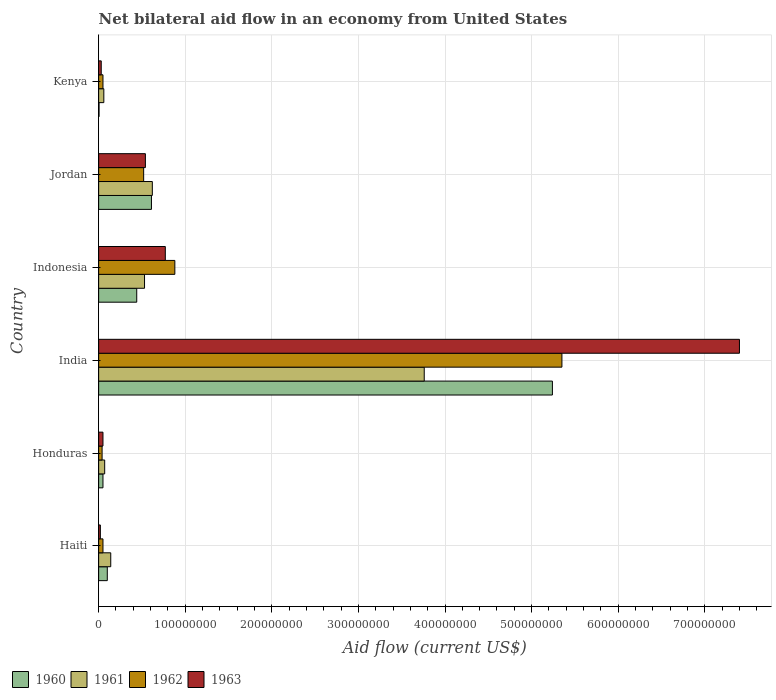Are the number of bars per tick equal to the number of legend labels?
Give a very brief answer. Yes. How many bars are there on the 6th tick from the top?
Ensure brevity in your answer.  4. What is the label of the 6th group of bars from the top?
Your response must be concise. Haiti. In how many cases, is the number of bars for a given country not equal to the number of legend labels?
Ensure brevity in your answer.  0. Across all countries, what is the maximum net bilateral aid flow in 1960?
Keep it short and to the point. 5.24e+08. In which country was the net bilateral aid flow in 1962 maximum?
Offer a terse response. India. In which country was the net bilateral aid flow in 1962 minimum?
Your answer should be very brief. Honduras. What is the total net bilateral aid flow in 1960 in the graph?
Provide a short and direct response. 6.44e+08. What is the difference between the net bilateral aid flow in 1963 in India and that in Kenya?
Keep it short and to the point. 7.37e+08. What is the difference between the net bilateral aid flow in 1962 in Kenya and the net bilateral aid flow in 1960 in Honduras?
Ensure brevity in your answer.  0. What is the average net bilateral aid flow in 1963 per country?
Offer a terse response. 1.47e+08. What is the difference between the net bilateral aid flow in 1962 and net bilateral aid flow in 1960 in Honduras?
Provide a succinct answer. -1.00e+06. What is the ratio of the net bilateral aid flow in 1962 in Honduras to that in India?
Give a very brief answer. 0.01. What is the difference between the highest and the second highest net bilateral aid flow in 1960?
Offer a very short reply. 4.63e+08. What is the difference between the highest and the lowest net bilateral aid flow in 1963?
Offer a very short reply. 7.38e+08. Is the sum of the net bilateral aid flow in 1962 in Indonesia and Jordan greater than the maximum net bilateral aid flow in 1960 across all countries?
Your answer should be very brief. No. What does the 2nd bar from the top in India represents?
Your response must be concise. 1962. How many bars are there?
Offer a very short reply. 24. How many countries are there in the graph?
Provide a short and direct response. 6. Does the graph contain grids?
Provide a succinct answer. Yes. Where does the legend appear in the graph?
Offer a terse response. Bottom left. How are the legend labels stacked?
Offer a very short reply. Horizontal. What is the title of the graph?
Ensure brevity in your answer.  Net bilateral aid flow in an economy from United States. What is the label or title of the X-axis?
Give a very brief answer. Aid flow (current US$). What is the Aid flow (current US$) of 1961 in Haiti?
Give a very brief answer. 1.40e+07. What is the Aid flow (current US$) in 1962 in Haiti?
Offer a very short reply. 5.00e+06. What is the Aid flow (current US$) of 1963 in Haiti?
Ensure brevity in your answer.  2.00e+06. What is the Aid flow (current US$) in 1960 in Honduras?
Provide a succinct answer. 5.00e+06. What is the Aid flow (current US$) of 1962 in Honduras?
Offer a very short reply. 4.00e+06. What is the Aid flow (current US$) in 1960 in India?
Provide a short and direct response. 5.24e+08. What is the Aid flow (current US$) in 1961 in India?
Ensure brevity in your answer.  3.76e+08. What is the Aid flow (current US$) in 1962 in India?
Keep it short and to the point. 5.35e+08. What is the Aid flow (current US$) of 1963 in India?
Give a very brief answer. 7.40e+08. What is the Aid flow (current US$) of 1960 in Indonesia?
Give a very brief answer. 4.40e+07. What is the Aid flow (current US$) of 1961 in Indonesia?
Offer a terse response. 5.30e+07. What is the Aid flow (current US$) in 1962 in Indonesia?
Offer a terse response. 8.80e+07. What is the Aid flow (current US$) in 1963 in Indonesia?
Make the answer very short. 7.70e+07. What is the Aid flow (current US$) in 1960 in Jordan?
Make the answer very short. 6.10e+07. What is the Aid flow (current US$) in 1961 in Jordan?
Ensure brevity in your answer.  6.20e+07. What is the Aid flow (current US$) in 1962 in Jordan?
Make the answer very short. 5.20e+07. What is the Aid flow (current US$) of 1963 in Jordan?
Ensure brevity in your answer.  5.40e+07. What is the Aid flow (current US$) in 1962 in Kenya?
Provide a succinct answer. 5.00e+06. What is the Aid flow (current US$) of 1963 in Kenya?
Your answer should be very brief. 3.00e+06. Across all countries, what is the maximum Aid flow (current US$) of 1960?
Provide a short and direct response. 5.24e+08. Across all countries, what is the maximum Aid flow (current US$) of 1961?
Offer a terse response. 3.76e+08. Across all countries, what is the maximum Aid flow (current US$) of 1962?
Keep it short and to the point. 5.35e+08. Across all countries, what is the maximum Aid flow (current US$) of 1963?
Provide a short and direct response. 7.40e+08. Across all countries, what is the minimum Aid flow (current US$) of 1961?
Provide a succinct answer. 6.00e+06. Across all countries, what is the minimum Aid flow (current US$) in 1962?
Provide a short and direct response. 4.00e+06. What is the total Aid flow (current US$) of 1960 in the graph?
Provide a short and direct response. 6.44e+08. What is the total Aid flow (current US$) of 1961 in the graph?
Provide a succinct answer. 5.18e+08. What is the total Aid flow (current US$) in 1962 in the graph?
Your response must be concise. 6.89e+08. What is the total Aid flow (current US$) of 1963 in the graph?
Give a very brief answer. 8.81e+08. What is the difference between the Aid flow (current US$) in 1960 in Haiti and that in Honduras?
Make the answer very short. 5.00e+06. What is the difference between the Aid flow (current US$) in 1961 in Haiti and that in Honduras?
Give a very brief answer. 7.00e+06. What is the difference between the Aid flow (current US$) in 1960 in Haiti and that in India?
Offer a very short reply. -5.14e+08. What is the difference between the Aid flow (current US$) of 1961 in Haiti and that in India?
Provide a short and direct response. -3.62e+08. What is the difference between the Aid flow (current US$) of 1962 in Haiti and that in India?
Your answer should be very brief. -5.30e+08. What is the difference between the Aid flow (current US$) of 1963 in Haiti and that in India?
Provide a succinct answer. -7.38e+08. What is the difference between the Aid flow (current US$) of 1960 in Haiti and that in Indonesia?
Provide a short and direct response. -3.40e+07. What is the difference between the Aid flow (current US$) in 1961 in Haiti and that in Indonesia?
Ensure brevity in your answer.  -3.90e+07. What is the difference between the Aid flow (current US$) of 1962 in Haiti and that in Indonesia?
Your answer should be compact. -8.30e+07. What is the difference between the Aid flow (current US$) of 1963 in Haiti and that in Indonesia?
Your answer should be very brief. -7.50e+07. What is the difference between the Aid flow (current US$) of 1960 in Haiti and that in Jordan?
Your answer should be very brief. -5.10e+07. What is the difference between the Aid flow (current US$) of 1961 in Haiti and that in Jordan?
Give a very brief answer. -4.80e+07. What is the difference between the Aid flow (current US$) in 1962 in Haiti and that in Jordan?
Offer a very short reply. -4.70e+07. What is the difference between the Aid flow (current US$) in 1963 in Haiti and that in Jordan?
Give a very brief answer. -5.20e+07. What is the difference between the Aid flow (current US$) in 1960 in Haiti and that in Kenya?
Your answer should be compact. 9.52e+06. What is the difference between the Aid flow (current US$) in 1961 in Haiti and that in Kenya?
Provide a short and direct response. 8.00e+06. What is the difference between the Aid flow (current US$) in 1962 in Haiti and that in Kenya?
Offer a terse response. 0. What is the difference between the Aid flow (current US$) of 1960 in Honduras and that in India?
Your response must be concise. -5.19e+08. What is the difference between the Aid flow (current US$) in 1961 in Honduras and that in India?
Provide a succinct answer. -3.69e+08. What is the difference between the Aid flow (current US$) in 1962 in Honduras and that in India?
Make the answer very short. -5.31e+08. What is the difference between the Aid flow (current US$) in 1963 in Honduras and that in India?
Your answer should be compact. -7.35e+08. What is the difference between the Aid flow (current US$) of 1960 in Honduras and that in Indonesia?
Your answer should be compact. -3.90e+07. What is the difference between the Aid flow (current US$) of 1961 in Honduras and that in Indonesia?
Make the answer very short. -4.60e+07. What is the difference between the Aid flow (current US$) in 1962 in Honduras and that in Indonesia?
Make the answer very short. -8.40e+07. What is the difference between the Aid flow (current US$) of 1963 in Honduras and that in Indonesia?
Offer a terse response. -7.20e+07. What is the difference between the Aid flow (current US$) in 1960 in Honduras and that in Jordan?
Keep it short and to the point. -5.60e+07. What is the difference between the Aid flow (current US$) of 1961 in Honduras and that in Jordan?
Ensure brevity in your answer.  -5.50e+07. What is the difference between the Aid flow (current US$) of 1962 in Honduras and that in Jordan?
Provide a short and direct response. -4.80e+07. What is the difference between the Aid flow (current US$) of 1963 in Honduras and that in Jordan?
Offer a very short reply. -4.90e+07. What is the difference between the Aid flow (current US$) in 1960 in Honduras and that in Kenya?
Keep it short and to the point. 4.52e+06. What is the difference between the Aid flow (current US$) in 1961 in Honduras and that in Kenya?
Your answer should be very brief. 1.00e+06. What is the difference between the Aid flow (current US$) of 1962 in Honduras and that in Kenya?
Keep it short and to the point. -1.00e+06. What is the difference between the Aid flow (current US$) in 1963 in Honduras and that in Kenya?
Make the answer very short. 2.00e+06. What is the difference between the Aid flow (current US$) in 1960 in India and that in Indonesia?
Provide a short and direct response. 4.80e+08. What is the difference between the Aid flow (current US$) in 1961 in India and that in Indonesia?
Offer a terse response. 3.23e+08. What is the difference between the Aid flow (current US$) of 1962 in India and that in Indonesia?
Give a very brief answer. 4.47e+08. What is the difference between the Aid flow (current US$) in 1963 in India and that in Indonesia?
Offer a very short reply. 6.63e+08. What is the difference between the Aid flow (current US$) in 1960 in India and that in Jordan?
Provide a succinct answer. 4.63e+08. What is the difference between the Aid flow (current US$) of 1961 in India and that in Jordan?
Ensure brevity in your answer.  3.14e+08. What is the difference between the Aid flow (current US$) of 1962 in India and that in Jordan?
Give a very brief answer. 4.83e+08. What is the difference between the Aid flow (current US$) of 1963 in India and that in Jordan?
Offer a terse response. 6.86e+08. What is the difference between the Aid flow (current US$) of 1960 in India and that in Kenya?
Offer a terse response. 5.24e+08. What is the difference between the Aid flow (current US$) in 1961 in India and that in Kenya?
Give a very brief answer. 3.70e+08. What is the difference between the Aid flow (current US$) in 1962 in India and that in Kenya?
Offer a terse response. 5.30e+08. What is the difference between the Aid flow (current US$) of 1963 in India and that in Kenya?
Offer a very short reply. 7.37e+08. What is the difference between the Aid flow (current US$) of 1960 in Indonesia and that in Jordan?
Make the answer very short. -1.70e+07. What is the difference between the Aid flow (current US$) in 1961 in Indonesia and that in Jordan?
Your response must be concise. -9.00e+06. What is the difference between the Aid flow (current US$) of 1962 in Indonesia and that in Jordan?
Make the answer very short. 3.60e+07. What is the difference between the Aid flow (current US$) in 1963 in Indonesia and that in Jordan?
Keep it short and to the point. 2.30e+07. What is the difference between the Aid flow (current US$) of 1960 in Indonesia and that in Kenya?
Offer a very short reply. 4.35e+07. What is the difference between the Aid flow (current US$) in 1961 in Indonesia and that in Kenya?
Provide a short and direct response. 4.70e+07. What is the difference between the Aid flow (current US$) in 1962 in Indonesia and that in Kenya?
Give a very brief answer. 8.30e+07. What is the difference between the Aid flow (current US$) of 1963 in Indonesia and that in Kenya?
Give a very brief answer. 7.40e+07. What is the difference between the Aid flow (current US$) of 1960 in Jordan and that in Kenya?
Your answer should be very brief. 6.05e+07. What is the difference between the Aid flow (current US$) in 1961 in Jordan and that in Kenya?
Provide a short and direct response. 5.60e+07. What is the difference between the Aid flow (current US$) in 1962 in Jordan and that in Kenya?
Your answer should be very brief. 4.70e+07. What is the difference between the Aid flow (current US$) in 1963 in Jordan and that in Kenya?
Give a very brief answer. 5.10e+07. What is the difference between the Aid flow (current US$) of 1960 in Haiti and the Aid flow (current US$) of 1961 in Honduras?
Provide a succinct answer. 3.00e+06. What is the difference between the Aid flow (current US$) in 1960 in Haiti and the Aid flow (current US$) in 1962 in Honduras?
Give a very brief answer. 6.00e+06. What is the difference between the Aid flow (current US$) in 1961 in Haiti and the Aid flow (current US$) in 1962 in Honduras?
Provide a short and direct response. 1.00e+07. What is the difference between the Aid flow (current US$) in 1961 in Haiti and the Aid flow (current US$) in 1963 in Honduras?
Offer a very short reply. 9.00e+06. What is the difference between the Aid flow (current US$) in 1960 in Haiti and the Aid flow (current US$) in 1961 in India?
Offer a very short reply. -3.66e+08. What is the difference between the Aid flow (current US$) in 1960 in Haiti and the Aid flow (current US$) in 1962 in India?
Your response must be concise. -5.25e+08. What is the difference between the Aid flow (current US$) of 1960 in Haiti and the Aid flow (current US$) of 1963 in India?
Provide a succinct answer. -7.30e+08. What is the difference between the Aid flow (current US$) in 1961 in Haiti and the Aid flow (current US$) in 1962 in India?
Keep it short and to the point. -5.21e+08. What is the difference between the Aid flow (current US$) of 1961 in Haiti and the Aid flow (current US$) of 1963 in India?
Give a very brief answer. -7.26e+08. What is the difference between the Aid flow (current US$) in 1962 in Haiti and the Aid flow (current US$) in 1963 in India?
Offer a terse response. -7.35e+08. What is the difference between the Aid flow (current US$) in 1960 in Haiti and the Aid flow (current US$) in 1961 in Indonesia?
Give a very brief answer. -4.30e+07. What is the difference between the Aid flow (current US$) in 1960 in Haiti and the Aid flow (current US$) in 1962 in Indonesia?
Give a very brief answer. -7.80e+07. What is the difference between the Aid flow (current US$) of 1960 in Haiti and the Aid flow (current US$) of 1963 in Indonesia?
Offer a very short reply. -6.70e+07. What is the difference between the Aid flow (current US$) of 1961 in Haiti and the Aid flow (current US$) of 1962 in Indonesia?
Ensure brevity in your answer.  -7.40e+07. What is the difference between the Aid flow (current US$) of 1961 in Haiti and the Aid flow (current US$) of 1963 in Indonesia?
Give a very brief answer. -6.30e+07. What is the difference between the Aid flow (current US$) in 1962 in Haiti and the Aid flow (current US$) in 1963 in Indonesia?
Make the answer very short. -7.20e+07. What is the difference between the Aid flow (current US$) in 1960 in Haiti and the Aid flow (current US$) in 1961 in Jordan?
Your answer should be very brief. -5.20e+07. What is the difference between the Aid flow (current US$) of 1960 in Haiti and the Aid flow (current US$) of 1962 in Jordan?
Make the answer very short. -4.20e+07. What is the difference between the Aid flow (current US$) of 1960 in Haiti and the Aid flow (current US$) of 1963 in Jordan?
Keep it short and to the point. -4.40e+07. What is the difference between the Aid flow (current US$) in 1961 in Haiti and the Aid flow (current US$) in 1962 in Jordan?
Give a very brief answer. -3.80e+07. What is the difference between the Aid flow (current US$) in 1961 in Haiti and the Aid flow (current US$) in 1963 in Jordan?
Make the answer very short. -4.00e+07. What is the difference between the Aid flow (current US$) of 1962 in Haiti and the Aid flow (current US$) of 1963 in Jordan?
Provide a short and direct response. -4.90e+07. What is the difference between the Aid flow (current US$) of 1960 in Haiti and the Aid flow (current US$) of 1961 in Kenya?
Offer a terse response. 4.00e+06. What is the difference between the Aid flow (current US$) in 1960 in Haiti and the Aid flow (current US$) in 1962 in Kenya?
Keep it short and to the point. 5.00e+06. What is the difference between the Aid flow (current US$) in 1961 in Haiti and the Aid flow (current US$) in 1962 in Kenya?
Give a very brief answer. 9.00e+06. What is the difference between the Aid flow (current US$) of 1961 in Haiti and the Aid flow (current US$) of 1963 in Kenya?
Offer a terse response. 1.10e+07. What is the difference between the Aid flow (current US$) of 1960 in Honduras and the Aid flow (current US$) of 1961 in India?
Offer a very short reply. -3.71e+08. What is the difference between the Aid flow (current US$) of 1960 in Honduras and the Aid flow (current US$) of 1962 in India?
Give a very brief answer. -5.30e+08. What is the difference between the Aid flow (current US$) of 1960 in Honduras and the Aid flow (current US$) of 1963 in India?
Ensure brevity in your answer.  -7.35e+08. What is the difference between the Aid flow (current US$) in 1961 in Honduras and the Aid flow (current US$) in 1962 in India?
Your answer should be compact. -5.28e+08. What is the difference between the Aid flow (current US$) of 1961 in Honduras and the Aid flow (current US$) of 1963 in India?
Provide a short and direct response. -7.33e+08. What is the difference between the Aid flow (current US$) in 1962 in Honduras and the Aid flow (current US$) in 1963 in India?
Make the answer very short. -7.36e+08. What is the difference between the Aid flow (current US$) in 1960 in Honduras and the Aid flow (current US$) in 1961 in Indonesia?
Offer a very short reply. -4.80e+07. What is the difference between the Aid flow (current US$) of 1960 in Honduras and the Aid flow (current US$) of 1962 in Indonesia?
Your answer should be compact. -8.30e+07. What is the difference between the Aid flow (current US$) in 1960 in Honduras and the Aid flow (current US$) in 1963 in Indonesia?
Offer a terse response. -7.20e+07. What is the difference between the Aid flow (current US$) of 1961 in Honduras and the Aid flow (current US$) of 1962 in Indonesia?
Offer a very short reply. -8.10e+07. What is the difference between the Aid flow (current US$) in 1961 in Honduras and the Aid flow (current US$) in 1963 in Indonesia?
Your answer should be compact. -7.00e+07. What is the difference between the Aid flow (current US$) in 1962 in Honduras and the Aid flow (current US$) in 1963 in Indonesia?
Offer a very short reply. -7.30e+07. What is the difference between the Aid flow (current US$) in 1960 in Honduras and the Aid flow (current US$) in 1961 in Jordan?
Ensure brevity in your answer.  -5.70e+07. What is the difference between the Aid flow (current US$) in 1960 in Honduras and the Aid flow (current US$) in 1962 in Jordan?
Make the answer very short. -4.70e+07. What is the difference between the Aid flow (current US$) in 1960 in Honduras and the Aid flow (current US$) in 1963 in Jordan?
Provide a short and direct response. -4.90e+07. What is the difference between the Aid flow (current US$) in 1961 in Honduras and the Aid flow (current US$) in 1962 in Jordan?
Provide a succinct answer. -4.50e+07. What is the difference between the Aid flow (current US$) in 1961 in Honduras and the Aid flow (current US$) in 1963 in Jordan?
Keep it short and to the point. -4.70e+07. What is the difference between the Aid flow (current US$) in 1962 in Honduras and the Aid flow (current US$) in 1963 in Jordan?
Offer a very short reply. -5.00e+07. What is the difference between the Aid flow (current US$) of 1960 in Honduras and the Aid flow (current US$) of 1962 in Kenya?
Provide a succinct answer. 0. What is the difference between the Aid flow (current US$) in 1961 in Honduras and the Aid flow (current US$) in 1963 in Kenya?
Make the answer very short. 4.00e+06. What is the difference between the Aid flow (current US$) of 1960 in India and the Aid flow (current US$) of 1961 in Indonesia?
Make the answer very short. 4.71e+08. What is the difference between the Aid flow (current US$) of 1960 in India and the Aid flow (current US$) of 1962 in Indonesia?
Ensure brevity in your answer.  4.36e+08. What is the difference between the Aid flow (current US$) of 1960 in India and the Aid flow (current US$) of 1963 in Indonesia?
Make the answer very short. 4.47e+08. What is the difference between the Aid flow (current US$) of 1961 in India and the Aid flow (current US$) of 1962 in Indonesia?
Make the answer very short. 2.88e+08. What is the difference between the Aid flow (current US$) of 1961 in India and the Aid flow (current US$) of 1963 in Indonesia?
Offer a terse response. 2.99e+08. What is the difference between the Aid flow (current US$) in 1962 in India and the Aid flow (current US$) in 1963 in Indonesia?
Ensure brevity in your answer.  4.58e+08. What is the difference between the Aid flow (current US$) in 1960 in India and the Aid flow (current US$) in 1961 in Jordan?
Your response must be concise. 4.62e+08. What is the difference between the Aid flow (current US$) in 1960 in India and the Aid flow (current US$) in 1962 in Jordan?
Provide a short and direct response. 4.72e+08. What is the difference between the Aid flow (current US$) in 1960 in India and the Aid flow (current US$) in 1963 in Jordan?
Keep it short and to the point. 4.70e+08. What is the difference between the Aid flow (current US$) in 1961 in India and the Aid flow (current US$) in 1962 in Jordan?
Provide a short and direct response. 3.24e+08. What is the difference between the Aid flow (current US$) in 1961 in India and the Aid flow (current US$) in 1963 in Jordan?
Give a very brief answer. 3.22e+08. What is the difference between the Aid flow (current US$) of 1962 in India and the Aid flow (current US$) of 1963 in Jordan?
Provide a short and direct response. 4.81e+08. What is the difference between the Aid flow (current US$) of 1960 in India and the Aid flow (current US$) of 1961 in Kenya?
Offer a very short reply. 5.18e+08. What is the difference between the Aid flow (current US$) in 1960 in India and the Aid flow (current US$) in 1962 in Kenya?
Provide a short and direct response. 5.19e+08. What is the difference between the Aid flow (current US$) in 1960 in India and the Aid flow (current US$) in 1963 in Kenya?
Make the answer very short. 5.21e+08. What is the difference between the Aid flow (current US$) of 1961 in India and the Aid flow (current US$) of 1962 in Kenya?
Your answer should be compact. 3.71e+08. What is the difference between the Aid flow (current US$) of 1961 in India and the Aid flow (current US$) of 1963 in Kenya?
Give a very brief answer. 3.73e+08. What is the difference between the Aid flow (current US$) in 1962 in India and the Aid flow (current US$) in 1963 in Kenya?
Provide a succinct answer. 5.32e+08. What is the difference between the Aid flow (current US$) in 1960 in Indonesia and the Aid flow (current US$) in 1961 in Jordan?
Your response must be concise. -1.80e+07. What is the difference between the Aid flow (current US$) of 1960 in Indonesia and the Aid flow (current US$) of 1962 in Jordan?
Your answer should be very brief. -8.00e+06. What is the difference between the Aid flow (current US$) of 1960 in Indonesia and the Aid flow (current US$) of 1963 in Jordan?
Keep it short and to the point. -1.00e+07. What is the difference between the Aid flow (current US$) of 1961 in Indonesia and the Aid flow (current US$) of 1962 in Jordan?
Ensure brevity in your answer.  1.00e+06. What is the difference between the Aid flow (current US$) of 1961 in Indonesia and the Aid flow (current US$) of 1963 in Jordan?
Your response must be concise. -1.00e+06. What is the difference between the Aid flow (current US$) of 1962 in Indonesia and the Aid flow (current US$) of 1963 in Jordan?
Your answer should be very brief. 3.40e+07. What is the difference between the Aid flow (current US$) in 1960 in Indonesia and the Aid flow (current US$) in 1961 in Kenya?
Keep it short and to the point. 3.80e+07. What is the difference between the Aid flow (current US$) in 1960 in Indonesia and the Aid flow (current US$) in 1962 in Kenya?
Your response must be concise. 3.90e+07. What is the difference between the Aid flow (current US$) in 1960 in Indonesia and the Aid flow (current US$) in 1963 in Kenya?
Keep it short and to the point. 4.10e+07. What is the difference between the Aid flow (current US$) in 1961 in Indonesia and the Aid flow (current US$) in 1962 in Kenya?
Provide a succinct answer. 4.80e+07. What is the difference between the Aid flow (current US$) of 1962 in Indonesia and the Aid flow (current US$) of 1963 in Kenya?
Your response must be concise. 8.50e+07. What is the difference between the Aid flow (current US$) in 1960 in Jordan and the Aid flow (current US$) in 1961 in Kenya?
Provide a succinct answer. 5.50e+07. What is the difference between the Aid flow (current US$) of 1960 in Jordan and the Aid flow (current US$) of 1962 in Kenya?
Your answer should be very brief. 5.60e+07. What is the difference between the Aid flow (current US$) of 1960 in Jordan and the Aid flow (current US$) of 1963 in Kenya?
Provide a short and direct response. 5.80e+07. What is the difference between the Aid flow (current US$) in 1961 in Jordan and the Aid flow (current US$) in 1962 in Kenya?
Offer a very short reply. 5.70e+07. What is the difference between the Aid flow (current US$) in 1961 in Jordan and the Aid flow (current US$) in 1963 in Kenya?
Your answer should be compact. 5.90e+07. What is the difference between the Aid flow (current US$) of 1962 in Jordan and the Aid flow (current US$) of 1963 in Kenya?
Your answer should be very brief. 4.90e+07. What is the average Aid flow (current US$) in 1960 per country?
Your answer should be compact. 1.07e+08. What is the average Aid flow (current US$) of 1961 per country?
Your response must be concise. 8.63e+07. What is the average Aid flow (current US$) in 1962 per country?
Ensure brevity in your answer.  1.15e+08. What is the average Aid flow (current US$) of 1963 per country?
Give a very brief answer. 1.47e+08. What is the difference between the Aid flow (current US$) in 1960 and Aid flow (current US$) in 1962 in Haiti?
Offer a very short reply. 5.00e+06. What is the difference between the Aid flow (current US$) in 1961 and Aid flow (current US$) in 1962 in Haiti?
Provide a short and direct response. 9.00e+06. What is the difference between the Aid flow (current US$) of 1961 and Aid flow (current US$) of 1963 in Haiti?
Make the answer very short. 1.20e+07. What is the difference between the Aid flow (current US$) of 1960 and Aid flow (current US$) of 1961 in Honduras?
Offer a terse response. -2.00e+06. What is the difference between the Aid flow (current US$) of 1960 and Aid flow (current US$) of 1962 in Honduras?
Keep it short and to the point. 1.00e+06. What is the difference between the Aid flow (current US$) in 1962 and Aid flow (current US$) in 1963 in Honduras?
Keep it short and to the point. -1.00e+06. What is the difference between the Aid flow (current US$) of 1960 and Aid flow (current US$) of 1961 in India?
Offer a terse response. 1.48e+08. What is the difference between the Aid flow (current US$) in 1960 and Aid flow (current US$) in 1962 in India?
Keep it short and to the point. -1.10e+07. What is the difference between the Aid flow (current US$) in 1960 and Aid flow (current US$) in 1963 in India?
Provide a succinct answer. -2.16e+08. What is the difference between the Aid flow (current US$) of 1961 and Aid flow (current US$) of 1962 in India?
Ensure brevity in your answer.  -1.59e+08. What is the difference between the Aid flow (current US$) of 1961 and Aid flow (current US$) of 1963 in India?
Provide a short and direct response. -3.64e+08. What is the difference between the Aid flow (current US$) of 1962 and Aid flow (current US$) of 1963 in India?
Your answer should be compact. -2.05e+08. What is the difference between the Aid flow (current US$) in 1960 and Aid flow (current US$) in 1961 in Indonesia?
Provide a short and direct response. -9.00e+06. What is the difference between the Aid flow (current US$) of 1960 and Aid flow (current US$) of 1962 in Indonesia?
Make the answer very short. -4.40e+07. What is the difference between the Aid flow (current US$) of 1960 and Aid flow (current US$) of 1963 in Indonesia?
Ensure brevity in your answer.  -3.30e+07. What is the difference between the Aid flow (current US$) in 1961 and Aid flow (current US$) in 1962 in Indonesia?
Keep it short and to the point. -3.50e+07. What is the difference between the Aid flow (current US$) in 1961 and Aid flow (current US$) in 1963 in Indonesia?
Provide a short and direct response. -2.40e+07. What is the difference between the Aid flow (current US$) in 1962 and Aid flow (current US$) in 1963 in Indonesia?
Your answer should be compact. 1.10e+07. What is the difference between the Aid flow (current US$) of 1960 and Aid flow (current US$) of 1961 in Jordan?
Provide a short and direct response. -1.00e+06. What is the difference between the Aid flow (current US$) of 1960 and Aid flow (current US$) of 1962 in Jordan?
Provide a short and direct response. 9.00e+06. What is the difference between the Aid flow (current US$) of 1961 and Aid flow (current US$) of 1962 in Jordan?
Your answer should be compact. 1.00e+07. What is the difference between the Aid flow (current US$) of 1961 and Aid flow (current US$) of 1963 in Jordan?
Offer a very short reply. 8.00e+06. What is the difference between the Aid flow (current US$) in 1960 and Aid flow (current US$) in 1961 in Kenya?
Your answer should be very brief. -5.52e+06. What is the difference between the Aid flow (current US$) in 1960 and Aid flow (current US$) in 1962 in Kenya?
Give a very brief answer. -4.52e+06. What is the difference between the Aid flow (current US$) of 1960 and Aid flow (current US$) of 1963 in Kenya?
Your answer should be very brief. -2.52e+06. What is the difference between the Aid flow (current US$) of 1961 and Aid flow (current US$) of 1962 in Kenya?
Provide a succinct answer. 1.00e+06. What is the difference between the Aid flow (current US$) of 1961 and Aid flow (current US$) of 1963 in Kenya?
Give a very brief answer. 3.00e+06. What is the difference between the Aid flow (current US$) of 1962 and Aid flow (current US$) of 1963 in Kenya?
Provide a succinct answer. 2.00e+06. What is the ratio of the Aid flow (current US$) of 1960 in Haiti to that in Honduras?
Your answer should be compact. 2. What is the ratio of the Aid flow (current US$) in 1961 in Haiti to that in Honduras?
Ensure brevity in your answer.  2. What is the ratio of the Aid flow (current US$) of 1963 in Haiti to that in Honduras?
Your response must be concise. 0.4. What is the ratio of the Aid flow (current US$) in 1960 in Haiti to that in India?
Give a very brief answer. 0.02. What is the ratio of the Aid flow (current US$) of 1961 in Haiti to that in India?
Provide a short and direct response. 0.04. What is the ratio of the Aid flow (current US$) in 1962 in Haiti to that in India?
Your answer should be very brief. 0.01. What is the ratio of the Aid flow (current US$) of 1963 in Haiti to that in India?
Your answer should be very brief. 0. What is the ratio of the Aid flow (current US$) of 1960 in Haiti to that in Indonesia?
Offer a terse response. 0.23. What is the ratio of the Aid flow (current US$) in 1961 in Haiti to that in Indonesia?
Your answer should be compact. 0.26. What is the ratio of the Aid flow (current US$) of 1962 in Haiti to that in Indonesia?
Ensure brevity in your answer.  0.06. What is the ratio of the Aid flow (current US$) of 1963 in Haiti to that in Indonesia?
Give a very brief answer. 0.03. What is the ratio of the Aid flow (current US$) of 1960 in Haiti to that in Jordan?
Give a very brief answer. 0.16. What is the ratio of the Aid flow (current US$) of 1961 in Haiti to that in Jordan?
Your answer should be very brief. 0.23. What is the ratio of the Aid flow (current US$) of 1962 in Haiti to that in Jordan?
Provide a short and direct response. 0.1. What is the ratio of the Aid flow (current US$) of 1963 in Haiti to that in Jordan?
Give a very brief answer. 0.04. What is the ratio of the Aid flow (current US$) in 1960 in Haiti to that in Kenya?
Provide a short and direct response. 20.83. What is the ratio of the Aid flow (current US$) of 1961 in Haiti to that in Kenya?
Make the answer very short. 2.33. What is the ratio of the Aid flow (current US$) in 1962 in Haiti to that in Kenya?
Provide a succinct answer. 1. What is the ratio of the Aid flow (current US$) in 1963 in Haiti to that in Kenya?
Provide a succinct answer. 0.67. What is the ratio of the Aid flow (current US$) in 1960 in Honduras to that in India?
Keep it short and to the point. 0.01. What is the ratio of the Aid flow (current US$) of 1961 in Honduras to that in India?
Your answer should be very brief. 0.02. What is the ratio of the Aid flow (current US$) of 1962 in Honduras to that in India?
Make the answer very short. 0.01. What is the ratio of the Aid flow (current US$) in 1963 in Honduras to that in India?
Provide a succinct answer. 0.01. What is the ratio of the Aid flow (current US$) of 1960 in Honduras to that in Indonesia?
Offer a very short reply. 0.11. What is the ratio of the Aid flow (current US$) of 1961 in Honduras to that in Indonesia?
Your answer should be very brief. 0.13. What is the ratio of the Aid flow (current US$) in 1962 in Honduras to that in Indonesia?
Give a very brief answer. 0.05. What is the ratio of the Aid flow (current US$) in 1963 in Honduras to that in Indonesia?
Provide a succinct answer. 0.06. What is the ratio of the Aid flow (current US$) of 1960 in Honduras to that in Jordan?
Make the answer very short. 0.08. What is the ratio of the Aid flow (current US$) of 1961 in Honduras to that in Jordan?
Offer a terse response. 0.11. What is the ratio of the Aid flow (current US$) of 1962 in Honduras to that in Jordan?
Your answer should be very brief. 0.08. What is the ratio of the Aid flow (current US$) of 1963 in Honduras to that in Jordan?
Provide a succinct answer. 0.09. What is the ratio of the Aid flow (current US$) of 1960 in Honduras to that in Kenya?
Your response must be concise. 10.42. What is the ratio of the Aid flow (current US$) in 1961 in Honduras to that in Kenya?
Keep it short and to the point. 1.17. What is the ratio of the Aid flow (current US$) of 1962 in Honduras to that in Kenya?
Keep it short and to the point. 0.8. What is the ratio of the Aid flow (current US$) in 1960 in India to that in Indonesia?
Offer a terse response. 11.91. What is the ratio of the Aid flow (current US$) in 1961 in India to that in Indonesia?
Provide a short and direct response. 7.09. What is the ratio of the Aid flow (current US$) of 1962 in India to that in Indonesia?
Make the answer very short. 6.08. What is the ratio of the Aid flow (current US$) in 1963 in India to that in Indonesia?
Your answer should be compact. 9.61. What is the ratio of the Aid flow (current US$) in 1960 in India to that in Jordan?
Give a very brief answer. 8.59. What is the ratio of the Aid flow (current US$) in 1961 in India to that in Jordan?
Your response must be concise. 6.06. What is the ratio of the Aid flow (current US$) of 1962 in India to that in Jordan?
Keep it short and to the point. 10.29. What is the ratio of the Aid flow (current US$) of 1963 in India to that in Jordan?
Your answer should be compact. 13.7. What is the ratio of the Aid flow (current US$) of 1960 in India to that in Kenya?
Provide a short and direct response. 1091.67. What is the ratio of the Aid flow (current US$) in 1961 in India to that in Kenya?
Provide a succinct answer. 62.67. What is the ratio of the Aid flow (current US$) in 1962 in India to that in Kenya?
Make the answer very short. 107. What is the ratio of the Aid flow (current US$) of 1963 in India to that in Kenya?
Offer a very short reply. 246.67. What is the ratio of the Aid flow (current US$) of 1960 in Indonesia to that in Jordan?
Your response must be concise. 0.72. What is the ratio of the Aid flow (current US$) of 1961 in Indonesia to that in Jordan?
Your response must be concise. 0.85. What is the ratio of the Aid flow (current US$) in 1962 in Indonesia to that in Jordan?
Provide a short and direct response. 1.69. What is the ratio of the Aid flow (current US$) in 1963 in Indonesia to that in Jordan?
Your answer should be compact. 1.43. What is the ratio of the Aid flow (current US$) in 1960 in Indonesia to that in Kenya?
Keep it short and to the point. 91.67. What is the ratio of the Aid flow (current US$) of 1961 in Indonesia to that in Kenya?
Your answer should be compact. 8.83. What is the ratio of the Aid flow (current US$) in 1963 in Indonesia to that in Kenya?
Your answer should be very brief. 25.67. What is the ratio of the Aid flow (current US$) in 1960 in Jordan to that in Kenya?
Offer a terse response. 127.08. What is the ratio of the Aid flow (current US$) of 1961 in Jordan to that in Kenya?
Offer a very short reply. 10.33. What is the ratio of the Aid flow (current US$) in 1963 in Jordan to that in Kenya?
Your answer should be compact. 18. What is the difference between the highest and the second highest Aid flow (current US$) in 1960?
Provide a short and direct response. 4.63e+08. What is the difference between the highest and the second highest Aid flow (current US$) of 1961?
Keep it short and to the point. 3.14e+08. What is the difference between the highest and the second highest Aid flow (current US$) of 1962?
Provide a short and direct response. 4.47e+08. What is the difference between the highest and the second highest Aid flow (current US$) in 1963?
Ensure brevity in your answer.  6.63e+08. What is the difference between the highest and the lowest Aid flow (current US$) in 1960?
Offer a very short reply. 5.24e+08. What is the difference between the highest and the lowest Aid flow (current US$) of 1961?
Your answer should be compact. 3.70e+08. What is the difference between the highest and the lowest Aid flow (current US$) in 1962?
Provide a succinct answer. 5.31e+08. What is the difference between the highest and the lowest Aid flow (current US$) in 1963?
Provide a succinct answer. 7.38e+08. 